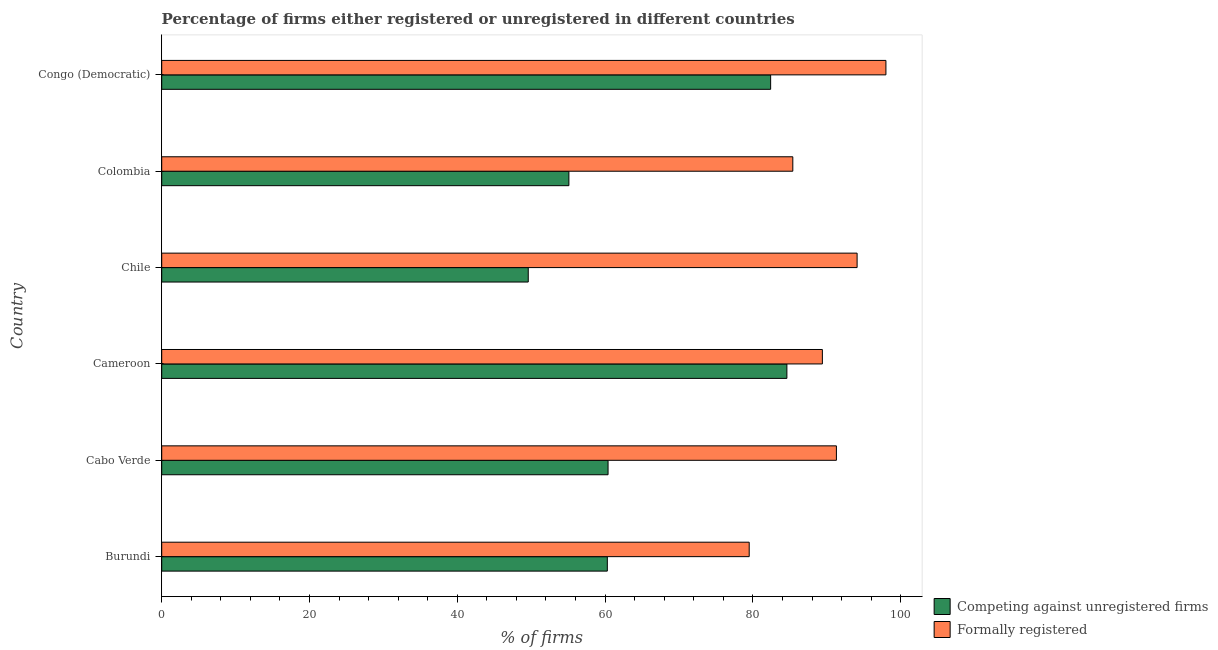How many bars are there on the 6th tick from the top?
Keep it short and to the point. 2. What is the label of the 6th group of bars from the top?
Your answer should be very brief. Burundi. In how many cases, is the number of bars for a given country not equal to the number of legend labels?
Keep it short and to the point. 0. What is the percentage of registered firms in Colombia?
Give a very brief answer. 55.1. Across all countries, what is the maximum percentage of registered firms?
Provide a short and direct response. 84.6. Across all countries, what is the minimum percentage of registered firms?
Provide a succinct answer. 49.6. In which country was the percentage of formally registered firms maximum?
Your response must be concise. Congo (Democratic). In which country was the percentage of formally registered firms minimum?
Your answer should be compact. Burundi. What is the total percentage of registered firms in the graph?
Make the answer very short. 392.4. What is the difference between the percentage of registered firms in Burundi and the percentage of formally registered firms in Cabo Verde?
Your answer should be compact. -31. What is the average percentage of registered firms per country?
Ensure brevity in your answer.  65.4. What is the difference between the percentage of formally registered firms and percentage of registered firms in Cameroon?
Your answer should be very brief. 4.8. In how many countries, is the percentage of formally registered firms greater than 8 %?
Keep it short and to the point. 6. What is the ratio of the percentage of formally registered firms in Cabo Verde to that in Congo (Democratic)?
Provide a succinct answer. 0.93. What is the difference between the highest and the second highest percentage of formally registered firms?
Provide a succinct answer. 3.9. Is the sum of the percentage of registered firms in Chile and Colombia greater than the maximum percentage of formally registered firms across all countries?
Keep it short and to the point. Yes. What does the 2nd bar from the top in Congo (Democratic) represents?
Offer a very short reply. Competing against unregistered firms. What does the 1st bar from the bottom in Chile represents?
Give a very brief answer. Competing against unregistered firms. How many bars are there?
Your answer should be very brief. 12. Are all the bars in the graph horizontal?
Offer a terse response. Yes. How many countries are there in the graph?
Offer a very short reply. 6. Are the values on the major ticks of X-axis written in scientific E-notation?
Ensure brevity in your answer.  No. How are the legend labels stacked?
Provide a short and direct response. Vertical. What is the title of the graph?
Offer a very short reply. Percentage of firms either registered or unregistered in different countries. What is the label or title of the X-axis?
Provide a short and direct response. % of firms. What is the % of firms in Competing against unregistered firms in Burundi?
Ensure brevity in your answer.  60.3. What is the % of firms in Formally registered in Burundi?
Make the answer very short. 79.5. What is the % of firms of Competing against unregistered firms in Cabo Verde?
Your answer should be very brief. 60.4. What is the % of firms in Formally registered in Cabo Verde?
Offer a terse response. 91.3. What is the % of firms of Competing against unregistered firms in Cameroon?
Offer a very short reply. 84.6. What is the % of firms of Formally registered in Cameroon?
Give a very brief answer. 89.4. What is the % of firms of Competing against unregistered firms in Chile?
Your response must be concise. 49.6. What is the % of firms in Formally registered in Chile?
Ensure brevity in your answer.  94.1. What is the % of firms in Competing against unregistered firms in Colombia?
Provide a succinct answer. 55.1. What is the % of firms of Formally registered in Colombia?
Your answer should be compact. 85.4. What is the % of firms of Competing against unregistered firms in Congo (Democratic)?
Offer a very short reply. 82.4. What is the % of firms of Formally registered in Congo (Democratic)?
Ensure brevity in your answer.  98. Across all countries, what is the maximum % of firms in Competing against unregistered firms?
Offer a terse response. 84.6. Across all countries, what is the minimum % of firms in Competing against unregistered firms?
Offer a terse response. 49.6. Across all countries, what is the minimum % of firms in Formally registered?
Provide a short and direct response. 79.5. What is the total % of firms in Competing against unregistered firms in the graph?
Offer a terse response. 392.4. What is the total % of firms of Formally registered in the graph?
Your answer should be very brief. 537.7. What is the difference between the % of firms of Formally registered in Burundi and that in Cabo Verde?
Your response must be concise. -11.8. What is the difference between the % of firms of Competing against unregistered firms in Burundi and that in Cameroon?
Give a very brief answer. -24.3. What is the difference between the % of firms in Formally registered in Burundi and that in Cameroon?
Offer a very short reply. -9.9. What is the difference between the % of firms in Formally registered in Burundi and that in Chile?
Make the answer very short. -14.6. What is the difference between the % of firms of Formally registered in Burundi and that in Colombia?
Ensure brevity in your answer.  -5.9. What is the difference between the % of firms in Competing against unregistered firms in Burundi and that in Congo (Democratic)?
Make the answer very short. -22.1. What is the difference between the % of firms in Formally registered in Burundi and that in Congo (Democratic)?
Ensure brevity in your answer.  -18.5. What is the difference between the % of firms of Competing against unregistered firms in Cabo Verde and that in Cameroon?
Offer a terse response. -24.2. What is the difference between the % of firms in Formally registered in Cabo Verde and that in Cameroon?
Make the answer very short. 1.9. What is the difference between the % of firms in Competing against unregistered firms in Cabo Verde and that in Chile?
Offer a very short reply. 10.8. What is the difference between the % of firms of Competing against unregistered firms in Cabo Verde and that in Colombia?
Your answer should be compact. 5.3. What is the difference between the % of firms in Formally registered in Cabo Verde and that in Colombia?
Offer a very short reply. 5.9. What is the difference between the % of firms of Competing against unregistered firms in Cameroon and that in Colombia?
Provide a short and direct response. 29.5. What is the difference between the % of firms in Formally registered in Cameroon and that in Colombia?
Your response must be concise. 4. What is the difference between the % of firms of Competing against unregistered firms in Chile and that in Congo (Democratic)?
Provide a succinct answer. -32.8. What is the difference between the % of firms in Formally registered in Chile and that in Congo (Democratic)?
Provide a succinct answer. -3.9. What is the difference between the % of firms of Competing against unregistered firms in Colombia and that in Congo (Democratic)?
Offer a very short reply. -27.3. What is the difference between the % of firms in Competing against unregistered firms in Burundi and the % of firms in Formally registered in Cabo Verde?
Keep it short and to the point. -31. What is the difference between the % of firms of Competing against unregistered firms in Burundi and the % of firms of Formally registered in Cameroon?
Make the answer very short. -29.1. What is the difference between the % of firms in Competing against unregistered firms in Burundi and the % of firms in Formally registered in Chile?
Ensure brevity in your answer.  -33.8. What is the difference between the % of firms in Competing against unregistered firms in Burundi and the % of firms in Formally registered in Colombia?
Offer a very short reply. -25.1. What is the difference between the % of firms in Competing against unregistered firms in Burundi and the % of firms in Formally registered in Congo (Democratic)?
Keep it short and to the point. -37.7. What is the difference between the % of firms in Competing against unregistered firms in Cabo Verde and the % of firms in Formally registered in Cameroon?
Make the answer very short. -29. What is the difference between the % of firms in Competing against unregistered firms in Cabo Verde and the % of firms in Formally registered in Chile?
Offer a terse response. -33.7. What is the difference between the % of firms in Competing against unregistered firms in Cabo Verde and the % of firms in Formally registered in Colombia?
Provide a succinct answer. -25. What is the difference between the % of firms of Competing against unregistered firms in Cabo Verde and the % of firms of Formally registered in Congo (Democratic)?
Your response must be concise. -37.6. What is the difference between the % of firms of Competing against unregistered firms in Chile and the % of firms of Formally registered in Colombia?
Give a very brief answer. -35.8. What is the difference between the % of firms of Competing against unregistered firms in Chile and the % of firms of Formally registered in Congo (Democratic)?
Your answer should be very brief. -48.4. What is the difference between the % of firms of Competing against unregistered firms in Colombia and the % of firms of Formally registered in Congo (Democratic)?
Offer a very short reply. -42.9. What is the average % of firms of Competing against unregistered firms per country?
Offer a terse response. 65.4. What is the average % of firms of Formally registered per country?
Offer a very short reply. 89.62. What is the difference between the % of firms in Competing against unregistered firms and % of firms in Formally registered in Burundi?
Offer a terse response. -19.2. What is the difference between the % of firms in Competing against unregistered firms and % of firms in Formally registered in Cabo Verde?
Make the answer very short. -30.9. What is the difference between the % of firms of Competing against unregistered firms and % of firms of Formally registered in Cameroon?
Provide a short and direct response. -4.8. What is the difference between the % of firms in Competing against unregistered firms and % of firms in Formally registered in Chile?
Your response must be concise. -44.5. What is the difference between the % of firms in Competing against unregistered firms and % of firms in Formally registered in Colombia?
Keep it short and to the point. -30.3. What is the difference between the % of firms of Competing against unregistered firms and % of firms of Formally registered in Congo (Democratic)?
Your response must be concise. -15.6. What is the ratio of the % of firms of Formally registered in Burundi to that in Cabo Verde?
Offer a very short reply. 0.87. What is the ratio of the % of firms of Competing against unregistered firms in Burundi to that in Cameroon?
Ensure brevity in your answer.  0.71. What is the ratio of the % of firms in Formally registered in Burundi to that in Cameroon?
Offer a very short reply. 0.89. What is the ratio of the % of firms in Competing against unregistered firms in Burundi to that in Chile?
Ensure brevity in your answer.  1.22. What is the ratio of the % of firms of Formally registered in Burundi to that in Chile?
Offer a terse response. 0.84. What is the ratio of the % of firms of Competing against unregistered firms in Burundi to that in Colombia?
Ensure brevity in your answer.  1.09. What is the ratio of the % of firms in Formally registered in Burundi to that in Colombia?
Your answer should be compact. 0.93. What is the ratio of the % of firms in Competing against unregistered firms in Burundi to that in Congo (Democratic)?
Give a very brief answer. 0.73. What is the ratio of the % of firms of Formally registered in Burundi to that in Congo (Democratic)?
Your answer should be very brief. 0.81. What is the ratio of the % of firms of Competing against unregistered firms in Cabo Verde to that in Cameroon?
Keep it short and to the point. 0.71. What is the ratio of the % of firms of Formally registered in Cabo Verde to that in Cameroon?
Provide a short and direct response. 1.02. What is the ratio of the % of firms in Competing against unregistered firms in Cabo Verde to that in Chile?
Provide a succinct answer. 1.22. What is the ratio of the % of firms of Formally registered in Cabo Verde to that in Chile?
Keep it short and to the point. 0.97. What is the ratio of the % of firms in Competing against unregistered firms in Cabo Verde to that in Colombia?
Offer a very short reply. 1.1. What is the ratio of the % of firms in Formally registered in Cabo Verde to that in Colombia?
Provide a short and direct response. 1.07. What is the ratio of the % of firms in Competing against unregistered firms in Cabo Verde to that in Congo (Democratic)?
Provide a short and direct response. 0.73. What is the ratio of the % of firms in Formally registered in Cabo Verde to that in Congo (Democratic)?
Keep it short and to the point. 0.93. What is the ratio of the % of firms of Competing against unregistered firms in Cameroon to that in Chile?
Give a very brief answer. 1.71. What is the ratio of the % of firms in Formally registered in Cameroon to that in Chile?
Your answer should be very brief. 0.95. What is the ratio of the % of firms of Competing against unregistered firms in Cameroon to that in Colombia?
Offer a very short reply. 1.54. What is the ratio of the % of firms in Formally registered in Cameroon to that in Colombia?
Provide a short and direct response. 1.05. What is the ratio of the % of firms of Competing against unregistered firms in Cameroon to that in Congo (Democratic)?
Your answer should be very brief. 1.03. What is the ratio of the % of firms of Formally registered in Cameroon to that in Congo (Democratic)?
Your response must be concise. 0.91. What is the ratio of the % of firms in Competing against unregistered firms in Chile to that in Colombia?
Make the answer very short. 0.9. What is the ratio of the % of firms of Formally registered in Chile to that in Colombia?
Your answer should be very brief. 1.1. What is the ratio of the % of firms in Competing against unregistered firms in Chile to that in Congo (Democratic)?
Give a very brief answer. 0.6. What is the ratio of the % of firms of Formally registered in Chile to that in Congo (Democratic)?
Provide a short and direct response. 0.96. What is the ratio of the % of firms in Competing against unregistered firms in Colombia to that in Congo (Democratic)?
Make the answer very short. 0.67. What is the ratio of the % of firms of Formally registered in Colombia to that in Congo (Democratic)?
Your answer should be compact. 0.87. What is the difference between the highest and the lowest % of firms in Competing against unregistered firms?
Your answer should be compact. 35. 